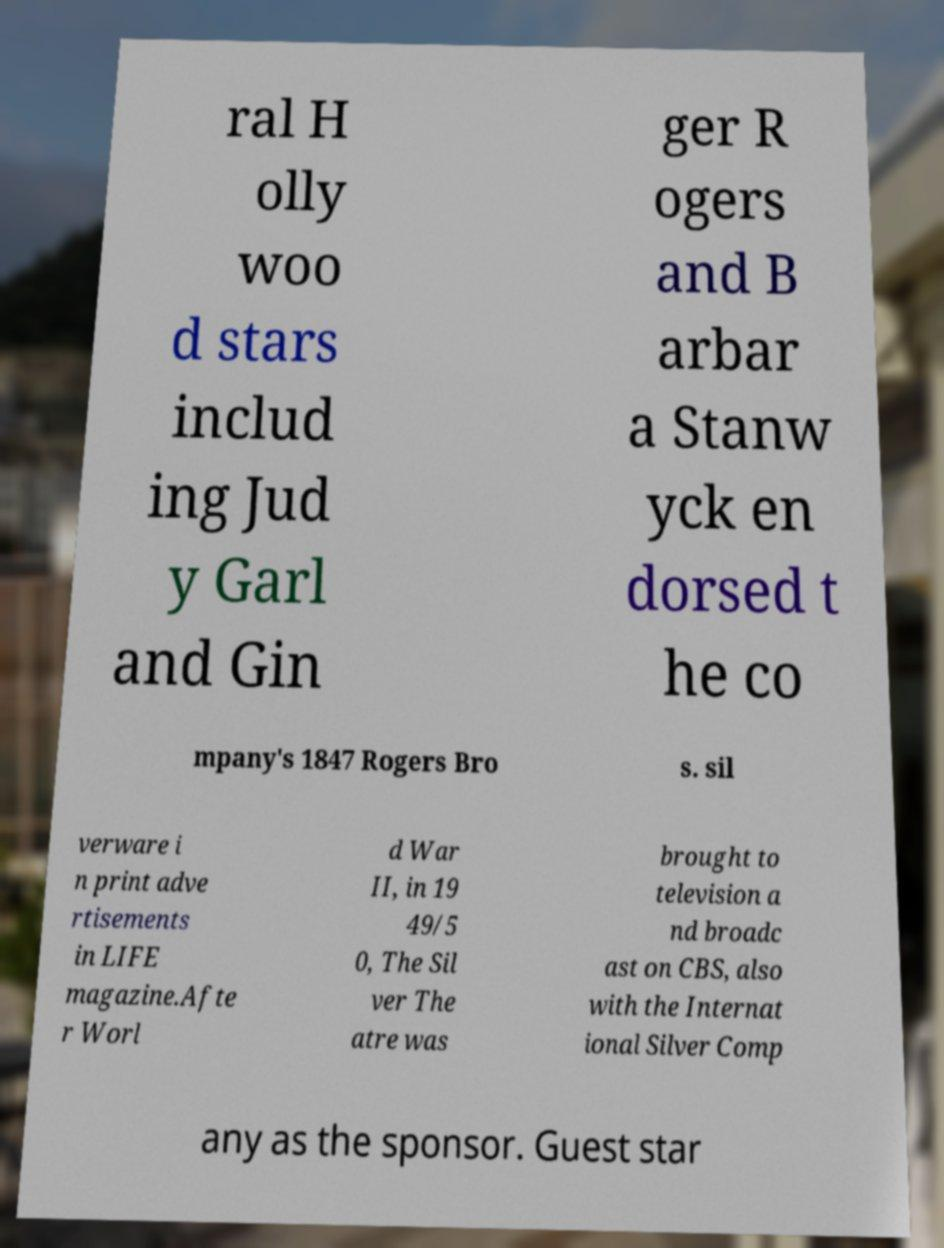Could you extract and type out the text from this image? ral H olly woo d stars includ ing Jud y Garl and Gin ger R ogers and B arbar a Stanw yck en dorsed t he co mpany's 1847 Rogers Bro s. sil verware i n print adve rtisements in LIFE magazine.Afte r Worl d War II, in 19 49/5 0, The Sil ver The atre was brought to television a nd broadc ast on CBS, also with the Internat ional Silver Comp any as the sponsor. Guest star 